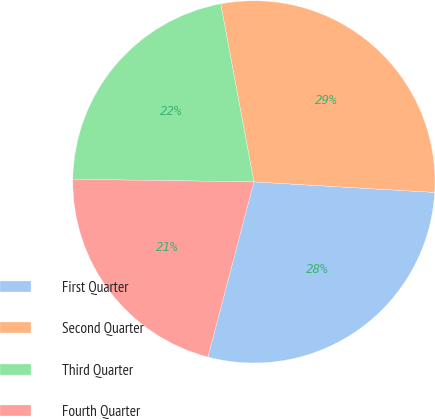<chart> <loc_0><loc_0><loc_500><loc_500><pie_chart><fcel>First Quarter<fcel>Second Quarter<fcel>Third Quarter<fcel>Fourth Quarter<nl><fcel>28.16%<fcel>28.86%<fcel>21.84%<fcel>21.14%<nl></chart> 